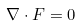<formula> <loc_0><loc_0><loc_500><loc_500>\nabla \cdot F = 0</formula> 